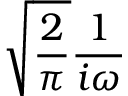<formula> <loc_0><loc_0><loc_500><loc_500>{ \sqrt { \frac { 2 } { \pi } } } { \frac { 1 } { i \omega } }</formula> 